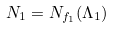<formula> <loc_0><loc_0><loc_500><loc_500>N _ { 1 } = N _ { f _ { 1 } } ( \Lambda _ { 1 } )</formula> 